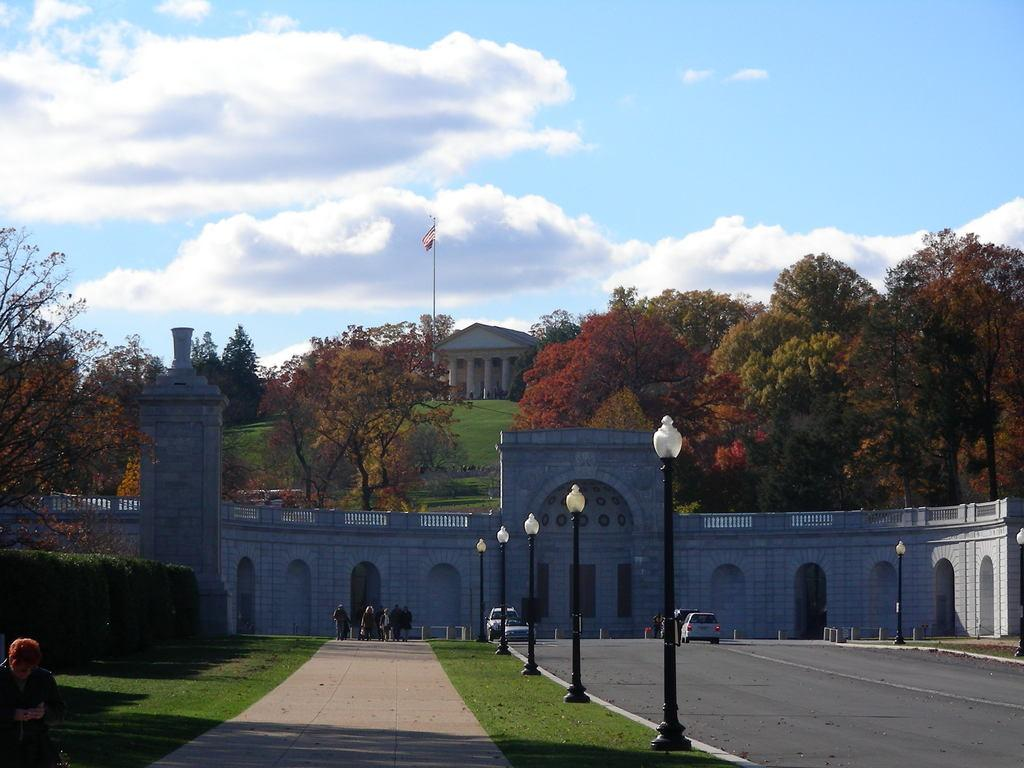What type of vehicles can be seen on the road in the image? There are cars on the road in the image. What structures are present in the image? There are poles, a wall, and a building in the image. What type of natural elements can be seen in the image? Grass, plants, and trees are visible in the image. What is visible in the background of the image? There is a building, a flag, and the sky in the background of the image. What can be seen in the sky? Clouds are present in the sky. How many flowers are being twisted by the people in the image? There are no flowers present in the image, and therefore no such activity can be observed. What type of memory is being stored in the building in the background of the image? The image does not provide any information about the building's function or purpose, so it is impossible to determine what type of memory, if any, is being stored there. 